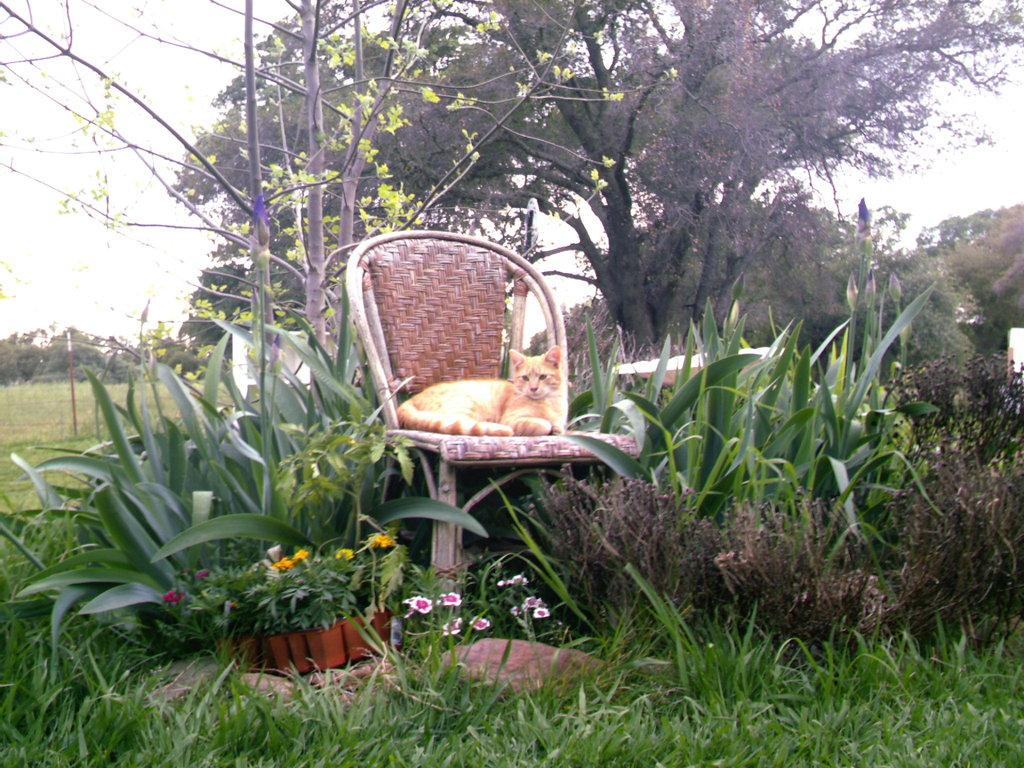What animal can be seen in the image? There is a cat in the image. Where is the cat located in the image? The cat is sitting on a chair. What can be seen in the background of the image? There is a small plant, a tree, and the sky visible in the background of the image. What color is the yam in the image? There is no yam present in the image. How many times has the cat folded its paws in the image? The cat's paws are not shown to be folded in the image. 